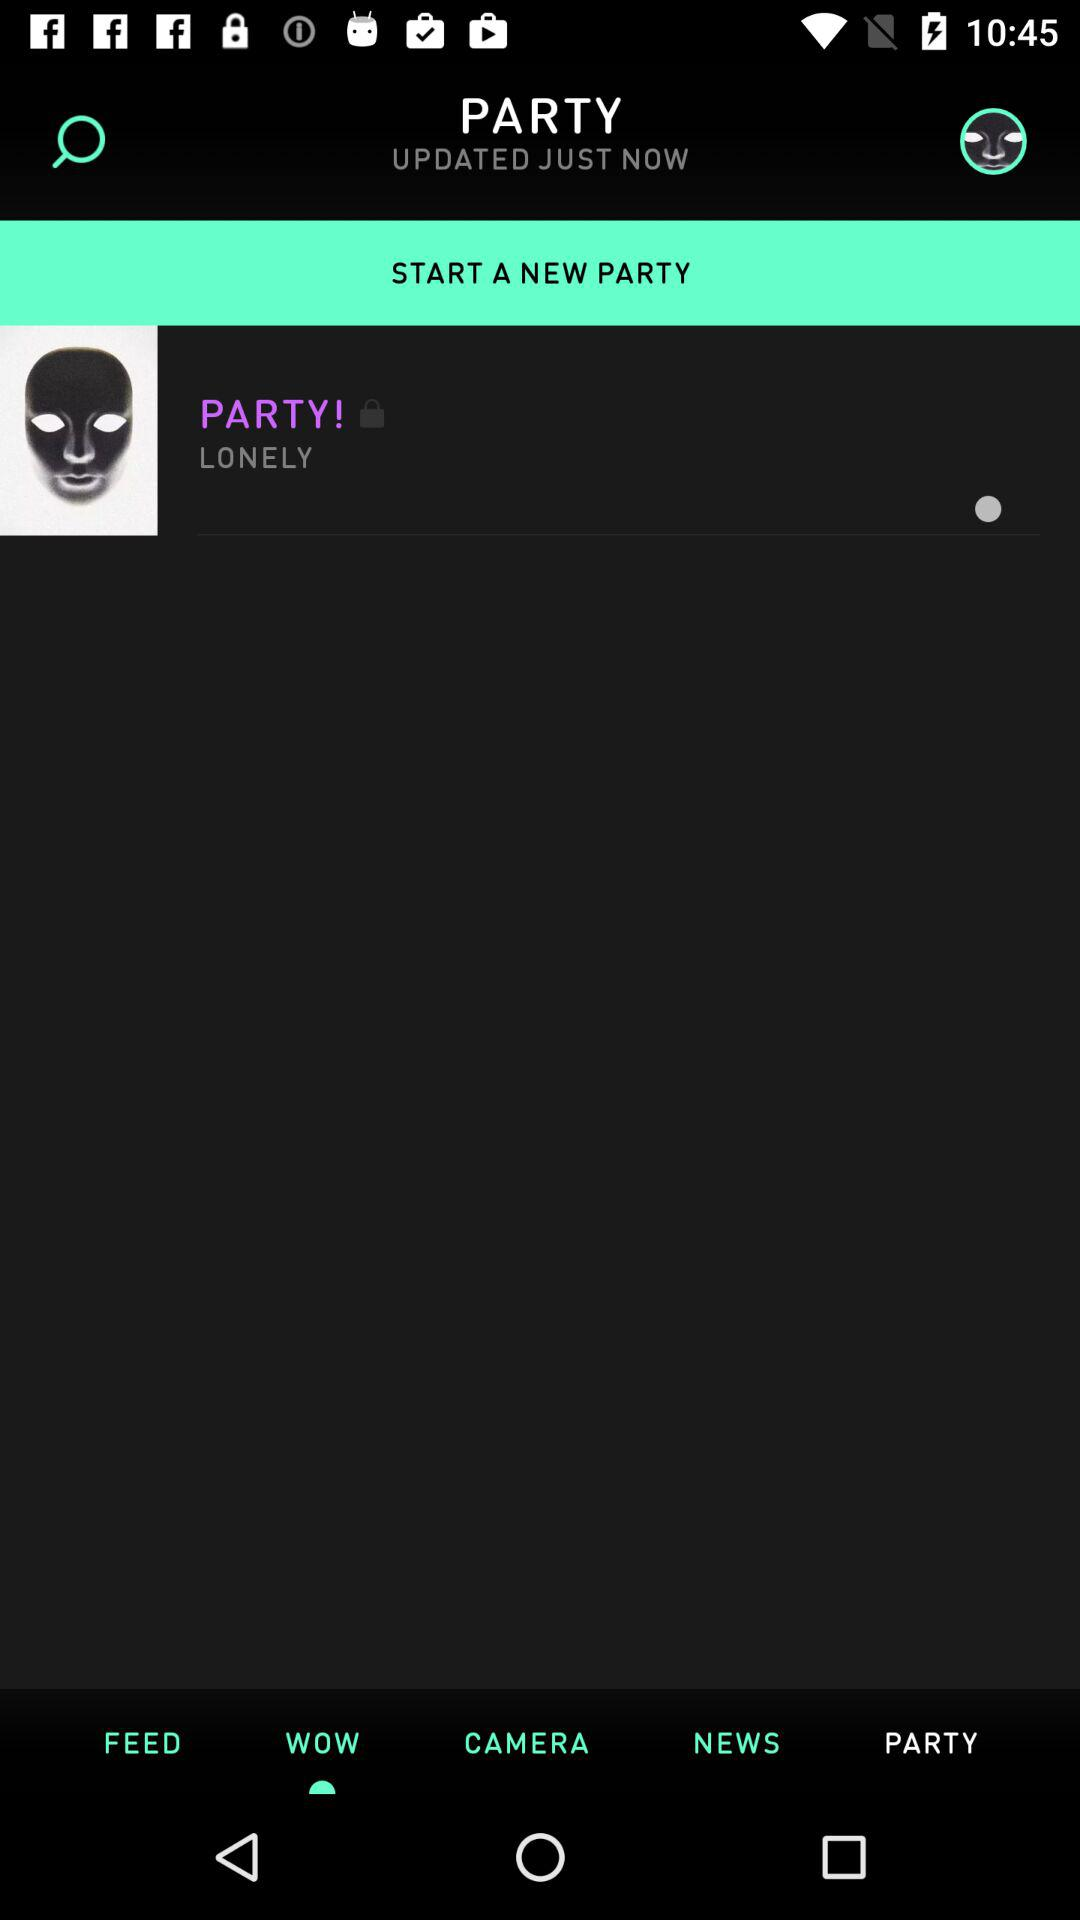Which is the selected tab? The selected tab is "WOW". 